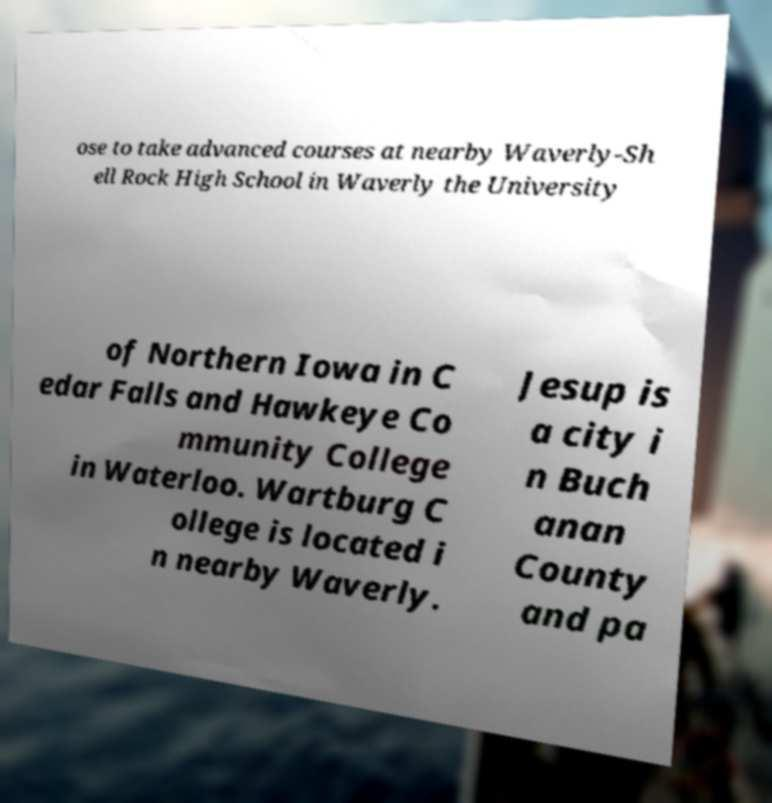Could you extract and type out the text from this image? ose to take advanced courses at nearby Waverly-Sh ell Rock High School in Waverly the University of Northern Iowa in C edar Falls and Hawkeye Co mmunity College in Waterloo. Wartburg C ollege is located i n nearby Waverly. Jesup is a city i n Buch anan County and pa 